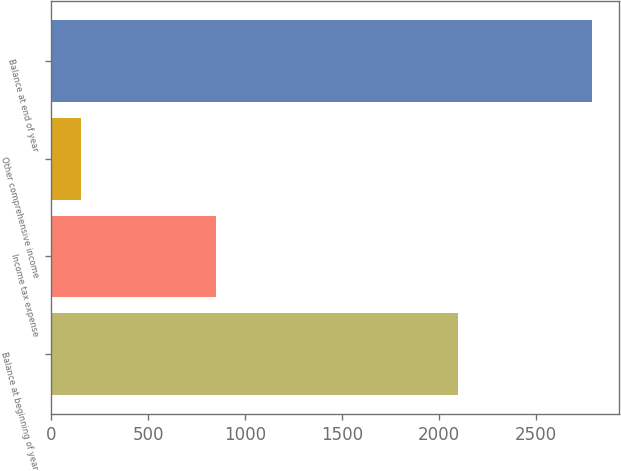<chart> <loc_0><loc_0><loc_500><loc_500><bar_chart><fcel>Balance at beginning of year<fcel>Income tax expense<fcel>Other comprehensive income<fcel>Balance at end of year<nl><fcel>2095<fcel>848<fcel>154<fcel>2789<nl></chart> 